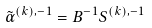<formula> <loc_0><loc_0><loc_500><loc_500>\tilde { \alpha } ^ { ( k ) , - 1 } = B ^ { - 1 } S ^ { ( k ) , - 1 }</formula> 